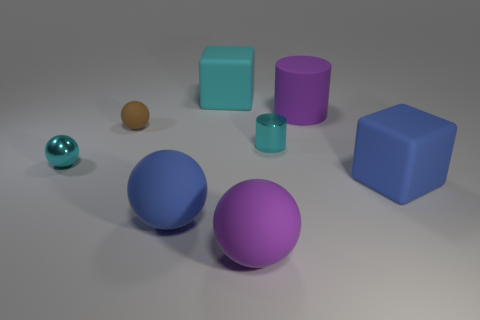What is the large block behind the large purple cylinder made of?
Your answer should be very brief. Rubber. What number of other large rubber things are the same shape as the cyan matte thing?
Provide a succinct answer. 1. Do the small cylinder and the small matte sphere have the same color?
Give a very brief answer. No. What material is the cylinder that is on the left side of the big matte cylinder that is right of the big purple matte object in front of the cyan metallic sphere made of?
Offer a very short reply. Metal. There is a purple cylinder; are there any purple matte cylinders left of it?
Offer a very short reply. No. There is a shiny object that is the same size as the metallic sphere; what is its shape?
Offer a very short reply. Cylinder. Is the material of the cyan sphere the same as the large cylinder?
Keep it short and to the point. No. What number of metallic objects are either tiny objects or big blue blocks?
Make the answer very short. 2. There is a metallic thing that is the same color as the shiny cylinder; what shape is it?
Offer a very short reply. Sphere. There is a matte sphere that is behind the large blue rubber ball; does it have the same color as the small metallic sphere?
Provide a short and direct response. No. 